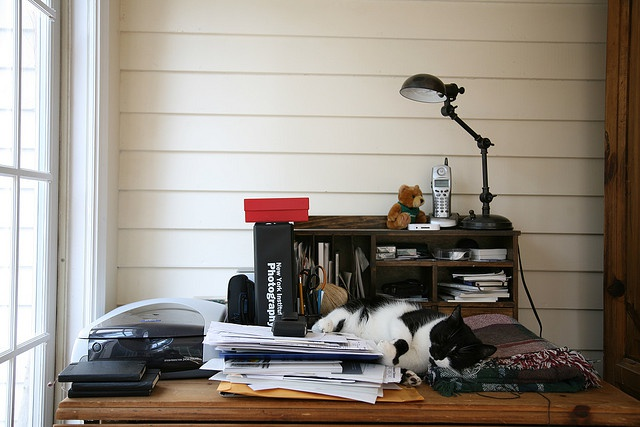Describe the objects in this image and their specific colors. I can see cat in white, black, lightgray, darkgray, and gray tones, book in white, black, and gray tones, teddy bear in white, maroon, black, and brown tones, book in white, black, darkblue, and gray tones, and book in white, black, darkgray, and gray tones in this image. 